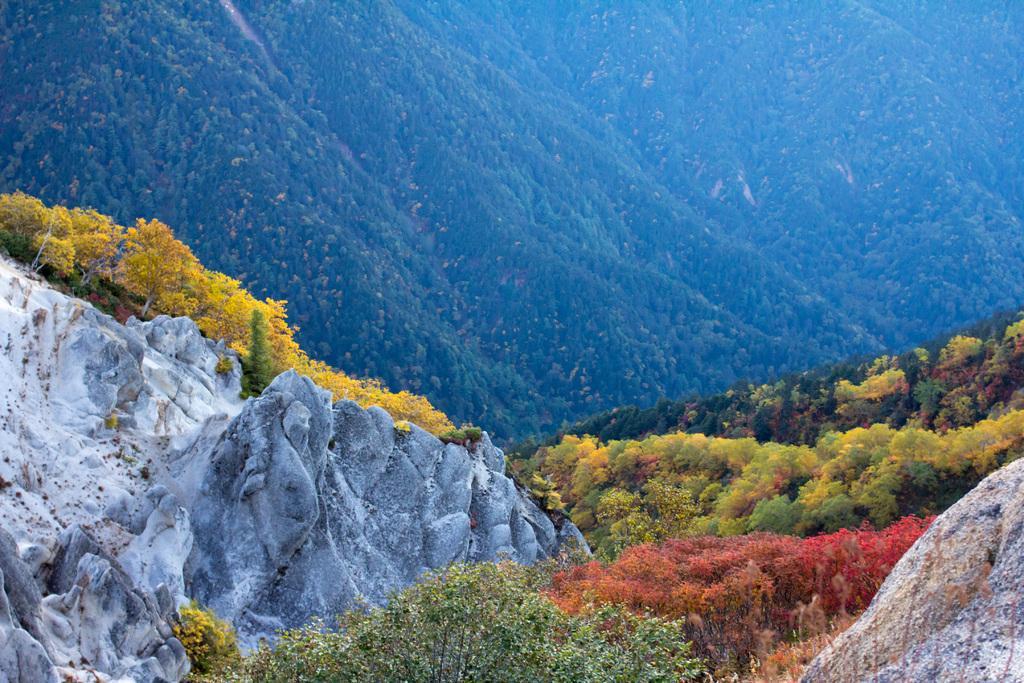How would you summarize this image in a sentence or two? It is a beautiful scenery, there are huge rocks and around those rocks there are beautiful trees and in the background there is a mountain. 